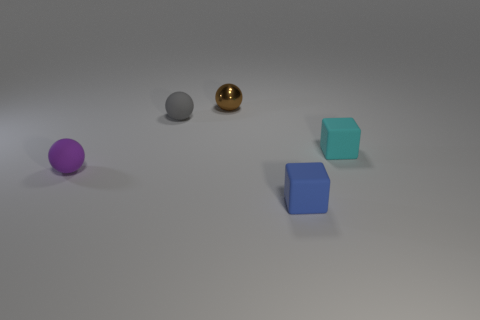Subtract all small rubber spheres. How many spheres are left? 1 Add 2 tiny yellow cubes. How many objects exist? 7 Subtract 1 blocks. How many blocks are left? 1 Subtract all spheres. How many objects are left? 2 Subtract all large green metal blocks. Subtract all small brown metal balls. How many objects are left? 4 Add 2 cyan matte blocks. How many cyan matte blocks are left? 3 Add 5 small brown metal balls. How many small brown metal balls exist? 6 Subtract 0 red blocks. How many objects are left? 5 Subtract all red blocks. Subtract all red balls. How many blocks are left? 2 